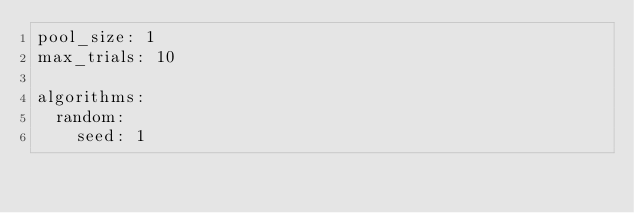<code> <loc_0><loc_0><loc_500><loc_500><_YAML_>pool_size: 1
max_trials: 10

algorithms:
  random:
    seed: 1
</code> 